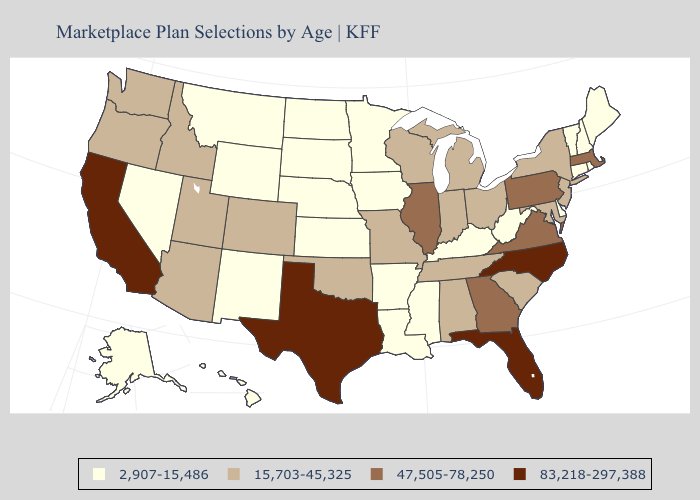Name the states that have a value in the range 83,218-297,388?
Quick response, please. California, Florida, North Carolina, Texas. Among the states that border Nebraska , which have the lowest value?
Concise answer only. Iowa, Kansas, South Dakota, Wyoming. Name the states that have a value in the range 47,505-78,250?
Concise answer only. Georgia, Illinois, Massachusetts, Pennsylvania, Virginia. What is the value of Mississippi?
Give a very brief answer. 2,907-15,486. Does the map have missing data?
Concise answer only. No. What is the lowest value in the South?
Give a very brief answer. 2,907-15,486. Name the states that have a value in the range 83,218-297,388?
Short answer required. California, Florida, North Carolina, Texas. Among the states that border Wisconsin , does Michigan have the lowest value?
Concise answer only. No. Which states have the lowest value in the USA?
Short answer required. Alaska, Arkansas, Connecticut, Delaware, Hawaii, Iowa, Kansas, Kentucky, Louisiana, Maine, Minnesota, Mississippi, Montana, Nebraska, Nevada, New Hampshire, New Mexico, North Dakota, Rhode Island, South Dakota, Vermont, West Virginia, Wyoming. Does Idaho have the same value as Maryland?
Short answer required. Yes. Which states hav the highest value in the MidWest?
Be succinct. Illinois. Among the states that border Idaho , which have the lowest value?
Write a very short answer. Montana, Nevada, Wyoming. Which states have the highest value in the USA?
Be succinct. California, Florida, North Carolina, Texas. Does the map have missing data?
Short answer required. No. 